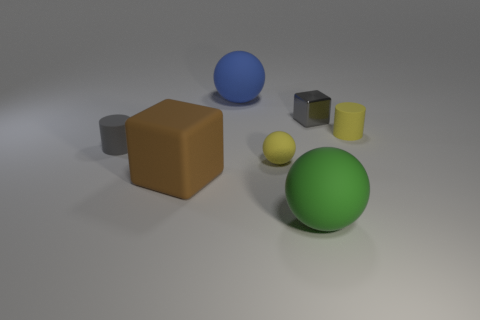The rubber cylinder that is the same color as the small metal object is what size?
Make the answer very short. Small. What color is the small cylinder that is to the right of the gray matte thing?
Ensure brevity in your answer.  Yellow. Do the brown matte object and the gray thing that is right of the blue object have the same shape?
Offer a terse response. Yes. Are there any matte things of the same color as the small metallic thing?
Provide a short and direct response. Yes. There is a block that is the same material as the yellow sphere; what is its size?
Make the answer very short. Large. Is the shape of the tiny yellow object that is right of the tiny metallic thing the same as  the gray matte object?
Ensure brevity in your answer.  Yes. What number of gray blocks have the same size as the gray cylinder?
Ensure brevity in your answer.  1. The other object that is the same color as the tiny metal object is what shape?
Your answer should be very brief. Cylinder. Are there any blue objects in front of the blue sphere that is left of the small ball?
Your response must be concise. No. What number of things are large matte things that are in front of the brown object or green spheres?
Keep it short and to the point. 1. 